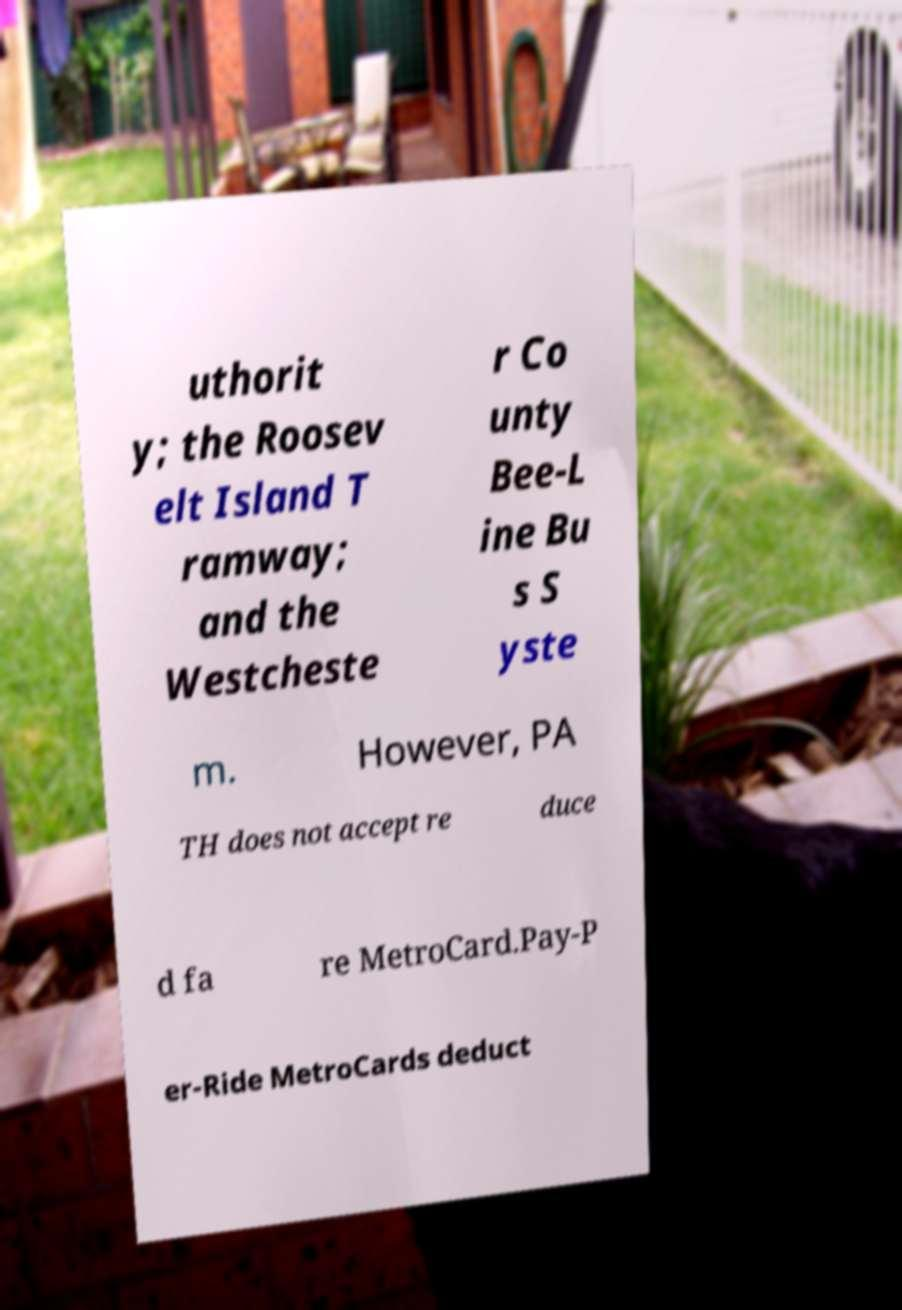What messages or text are displayed in this image? I need them in a readable, typed format. uthorit y; the Roosev elt Island T ramway; and the Westcheste r Co unty Bee-L ine Bu s S yste m. However, PA TH does not accept re duce d fa re MetroCard.Pay-P er-Ride MetroCards deduct 